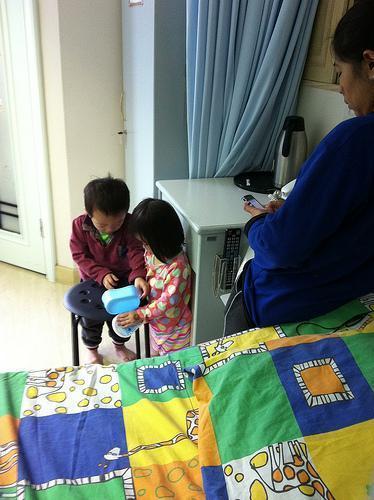How many people are in this picture?
Give a very brief answer. 3. 